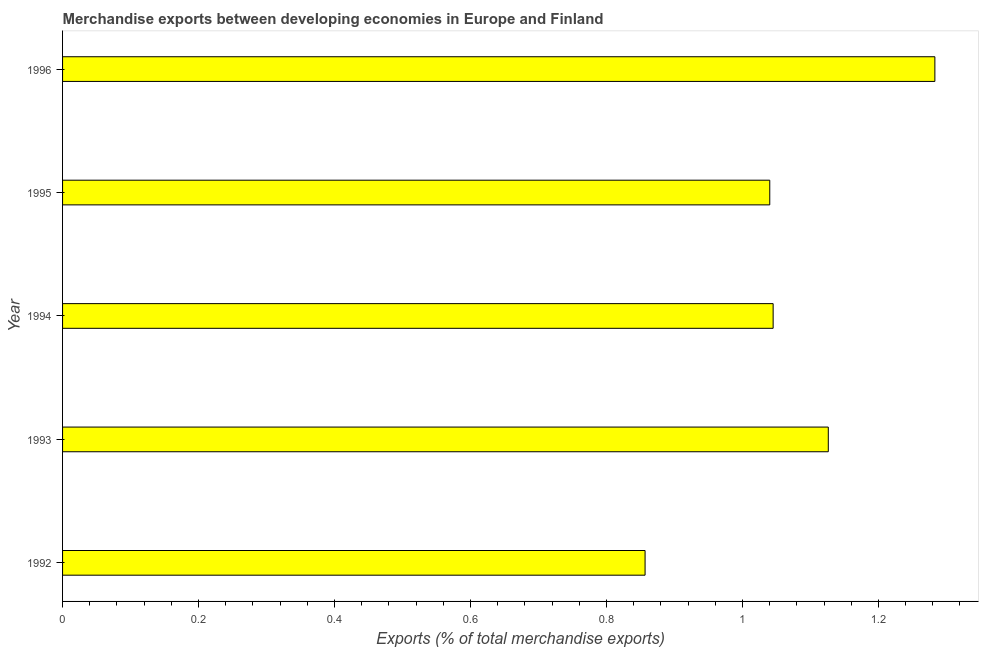What is the title of the graph?
Make the answer very short. Merchandise exports between developing economies in Europe and Finland. What is the label or title of the X-axis?
Your response must be concise. Exports (% of total merchandise exports). What is the label or title of the Y-axis?
Ensure brevity in your answer.  Year. What is the merchandise exports in 1994?
Your answer should be compact. 1.05. Across all years, what is the maximum merchandise exports?
Give a very brief answer. 1.28. Across all years, what is the minimum merchandise exports?
Your answer should be compact. 0.86. What is the sum of the merchandise exports?
Keep it short and to the point. 5.35. What is the difference between the merchandise exports in 1992 and 1995?
Your answer should be compact. -0.18. What is the average merchandise exports per year?
Your response must be concise. 1.07. What is the median merchandise exports?
Provide a succinct answer. 1.05. What is the ratio of the merchandise exports in 1992 to that in 1993?
Your answer should be very brief. 0.76. Is the merchandise exports in 1995 less than that in 1996?
Your answer should be very brief. Yes. Is the difference between the merchandise exports in 1993 and 1994 greater than the difference between any two years?
Offer a terse response. No. What is the difference between the highest and the second highest merchandise exports?
Ensure brevity in your answer.  0.16. What is the difference between the highest and the lowest merchandise exports?
Your response must be concise. 0.43. How many bars are there?
Your answer should be compact. 5. Are all the bars in the graph horizontal?
Provide a short and direct response. Yes. How many years are there in the graph?
Offer a terse response. 5. What is the difference between two consecutive major ticks on the X-axis?
Give a very brief answer. 0.2. Are the values on the major ticks of X-axis written in scientific E-notation?
Your response must be concise. No. What is the Exports (% of total merchandise exports) of 1992?
Your answer should be compact. 0.86. What is the Exports (% of total merchandise exports) in 1993?
Provide a succinct answer. 1.13. What is the Exports (% of total merchandise exports) of 1994?
Give a very brief answer. 1.05. What is the Exports (% of total merchandise exports) in 1995?
Provide a short and direct response. 1.04. What is the Exports (% of total merchandise exports) of 1996?
Provide a short and direct response. 1.28. What is the difference between the Exports (% of total merchandise exports) in 1992 and 1993?
Keep it short and to the point. -0.27. What is the difference between the Exports (% of total merchandise exports) in 1992 and 1994?
Offer a terse response. -0.19. What is the difference between the Exports (% of total merchandise exports) in 1992 and 1995?
Make the answer very short. -0.18. What is the difference between the Exports (% of total merchandise exports) in 1992 and 1996?
Provide a short and direct response. -0.43. What is the difference between the Exports (% of total merchandise exports) in 1993 and 1994?
Make the answer very short. 0.08. What is the difference between the Exports (% of total merchandise exports) in 1993 and 1995?
Make the answer very short. 0.09. What is the difference between the Exports (% of total merchandise exports) in 1993 and 1996?
Provide a succinct answer. -0.16. What is the difference between the Exports (% of total merchandise exports) in 1994 and 1995?
Your response must be concise. 0. What is the difference between the Exports (% of total merchandise exports) in 1994 and 1996?
Offer a very short reply. -0.24. What is the difference between the Exports (% of total merchandise exports) in 1995 and 1996?
Your answer should be compact. -0.24. What is the ratio of the Exports (% of total merchandise exports) in 1992 to that in 1993?
Your answer should be compact. 0.76. What is the ratio of the Exports (% of total merchandise exports) in 1992 to that in 1994?
Ensure brevity in your answer.  0.82. What is the ratio of the Exports (% of total merchandise exports) in 1992 to that in 1995?
Offer a terse response. 0.82. What is the ratio of the Exports (% of total merchandise exports) in 1992 to that in 1996?
Provide a short and direct response. 0.67. What is the ratio of the Exports (% of total merchandise exports) in 1993 to that in 1994?
Make the answer very short. 1.08. What is the ratio of the Exports (% of total merchandise exports) in 1993 to that in 1995?
Your response must be concise. 1.08. What is the ratio of the Exports (% of total merchandise exports) in 1993 to that in 1996?
Offer a very short reply. 0.88. What is the ratio of the Exports (% of total merchandise exports) in 1994 to that in 1996?
Give a very brief answer. 0.81. What is the ratio of the Exports (% of total merchandise exports) in 1995 to that in 1996?
Ensure brevity in your answer.  0.81. 